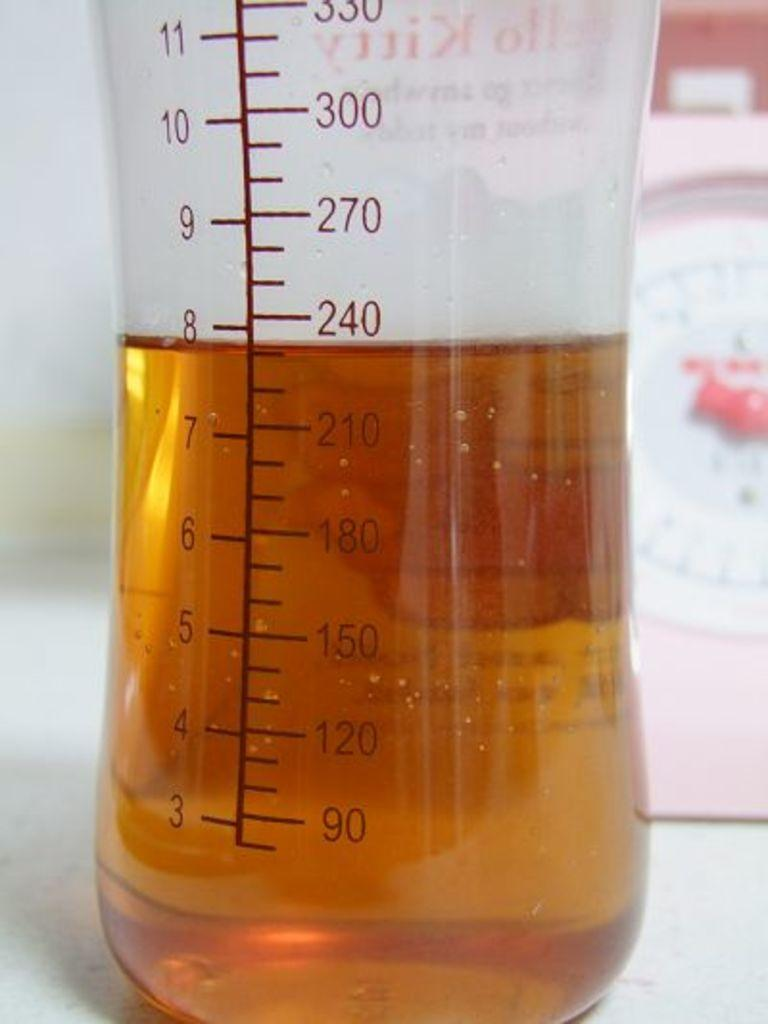<image>
Offer a succinct explanation of the picture presented. Measuring cup with numbers written in red from three to three hundred and thirty. 